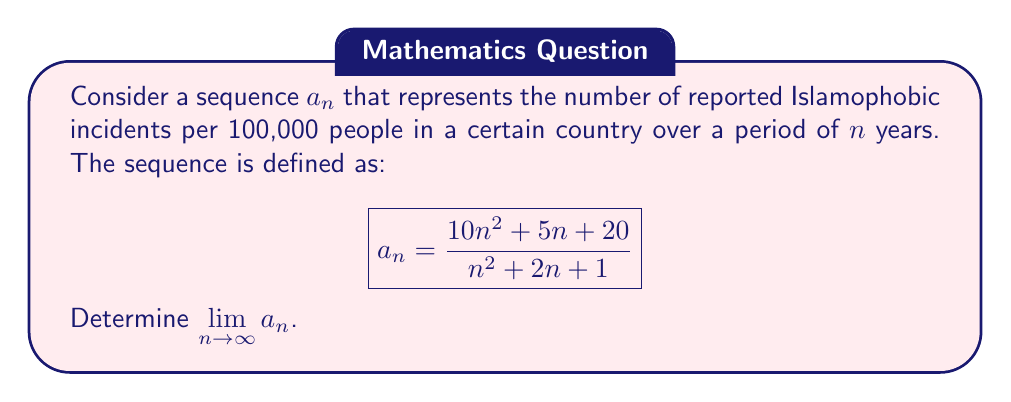Give your solution to this math problem. To find the limit of this sequence as $n$ approaches infinity, we can follow these steps:

1) First, let's examine the degrees of the numerator and denominator:
   - Numerator: $10n^2 + 5n + 20$ (degree 2)
   - Denominator: $n^2 + 2n + 1$ (degree 2)

2) Since both the numerator and denominator are polynomials of degree 2, we can use the limit of the ratio of the leading coefficients:

   $$\lim_{n \to \infty} a_n = \lim_{n \to \infty} \frac{10n^2 + 5n + 20}{n^2 + 2n + 1} = \frac{10}{1} = 10$$

3) To verify this result, we can use the division algorithm:

   $$\frac{10n^2 + 5n + 20}{n^2 + 2n + 1} = 10 + \frac{-15n - 10}{n^2 + 2n + 1}$$

4) Now, let's examine the limit of the remainder term:

   $$\lim_{n \to \infty} \frac{-15n - 10}{n^2 + 2n + 1} = \lim_{n \to \infty} \frac{-15 - \frac{10}{n}}{n + 2 + \frac{1}{n}} = 0$$

5) Therefore, we can conclude:

   $$\lim_{n \to \infty} a_n = 10 + 0 = 10$$

This result suggests that, in this model, the number of Islamophobic incidents per 100,000 people approaches 10 as time progresses indefinitely.
Answer: $\lim_{n \to \infty} a_n = 10$ 